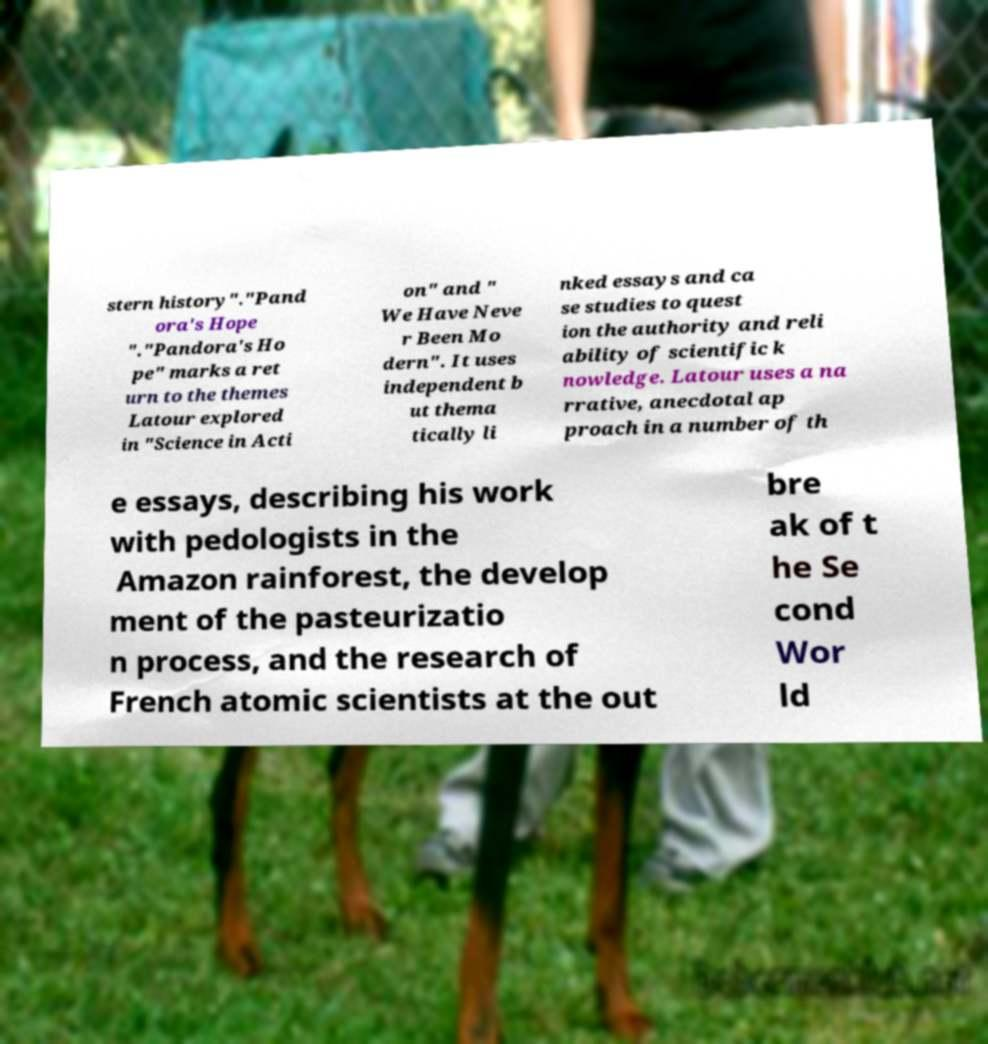There's text embedded in this image that I need extracted. Can you transcribe it verbatim? stern history"."Pand ora's Hope "."Pandora's Ho pe" marks a ret urn to the themes Latour explored in "Science in Acti on" and " We Have Neve r Been Mo dern". It uses independent b ut thema tically li nked essays and ca se studies to quest ion the authority and reli ability of scientific k nowledge. Latour uses a na rrative, anecdotal ap proach in a number of th e essays, describing his work with pedologists in the Amazon rainforest, the develop ment of the pasteurizatio n process, and the research of French atomic scientists at the out bre ak of t he Se cond Wor ld 